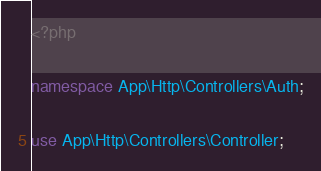Convert code to text. <code><loc_0><loc_0><loc_500><loc_500><_PHP_><?php

namespace App\Http\Controllers\Auth;

use App\Http\Controllers\Controller;</code> 